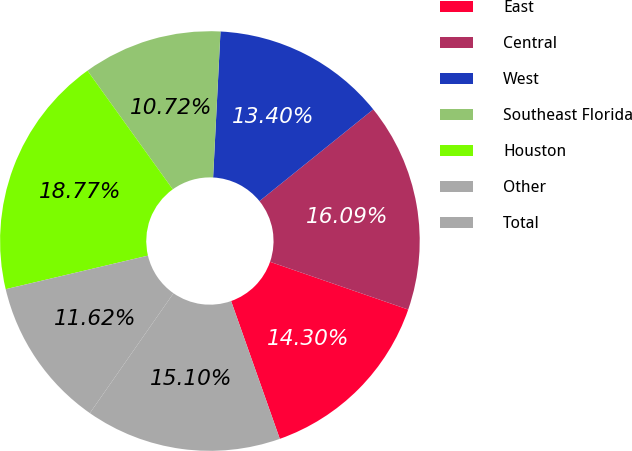Convert chart to OTSL. <chart><loc_0><loc_0><loc_500><loc_500><pie_chart><fcel>East<fcel>Central<fcel>West<fcel>Southeast Florida<fcel>Houston<fcel>Other<fcel>Total<nl><fcel>14.3%<fcel>16.09%<fcel>13.4%<fcel>10.72%<fcel>18.77%<fcel>11.62%<fcel>15.1%<nl></chart> 